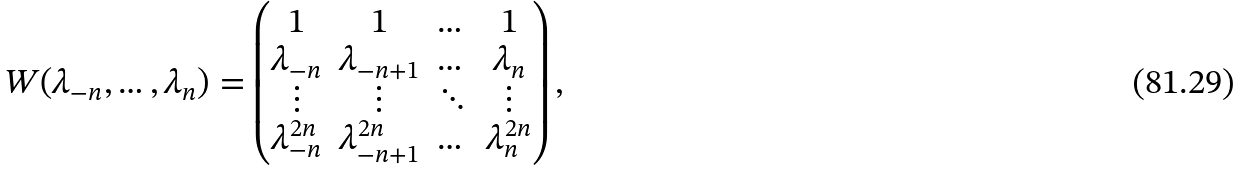<formula> <loc_0><loc_0><loc_500><loc_500>W ( \lambda _ { - n } , \dots , \lambda _ { n } ) = \begin{pmatrix} 1 & 1 & \dots & 1 \\ \lambda _ { - n } & \lambda _ { - n + 1 } & \dots & \lambda _ { n } \\ \vdots & \vdots & \ddots & \vdots \\ \lambda _ { - n } ^ { 2 n } & \lambda _ { - n + 1 } ^ { 2 n } & \dots & \lambda _ { n } ^ { 2 n } \end{pmatrix} ,</formula> 